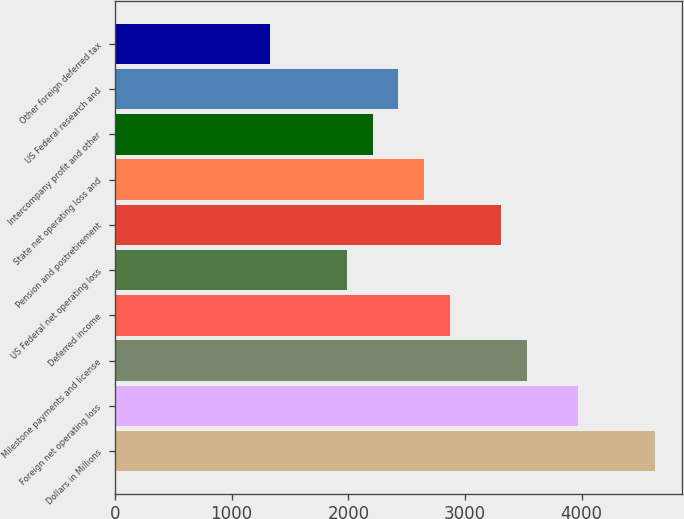Convert chart. <chart><loc_0><loc_0><loc_500><loc_500><bar_chart><fcel>Dollars in Millions<fcel>Foreign net operating loss<fcel>Milestone payments and license<fcel>Deferred income<fcel>US Federal net operating loss<fcel>Pension and postretirement<fcel>State net operating loss and<fcel>Intercompany profit and other<fcel>US Federal research and<fcel>Other foreign deferred tax<nl><fcel>4628<fcel>3968<fcel>3528<fcel>2868<fcel>1988<fcel>3308<fcel>2648<fcel>2208<fcel>2428<fcel>1328<nl></chart> 